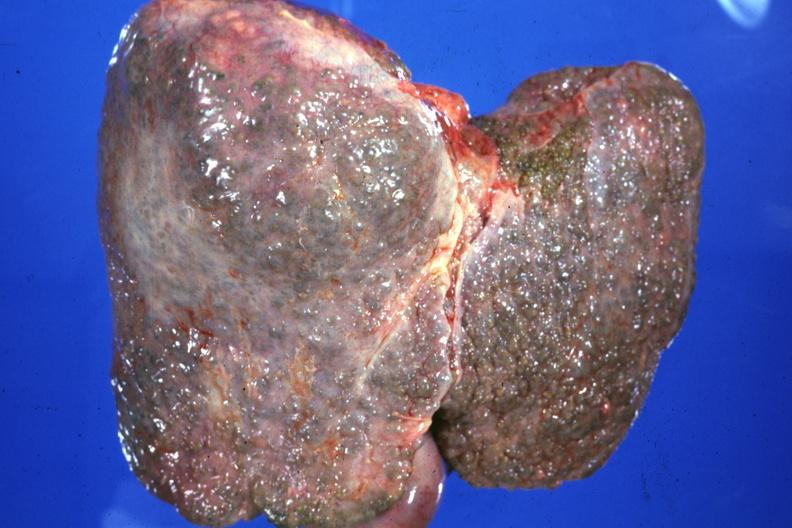s cephalohematoma present?
Answer the question using a single word or phrase. No 